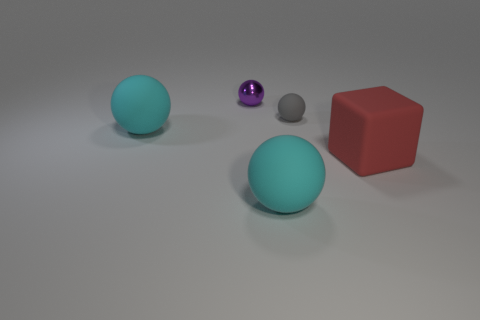There is a cyan matte ball in front of the red matte object; is it the same size as the tiny metal object?
Keep it short and to the point. No. Is the number of big cyan matte spheres in front of the large red matte block less than the number of big spheres that are to the left of the tiny gray rubber thing?
Make the answer very short. Yes. Is the matte block the same color as the metallic thing?
Provide a succinct answer. No. Are there fewer purple metal balls that are behind the small purple metal object than small gray matte balls?
Your answer should be compact. Yes. Do the big block and the purple sphere have the same material?
Provide a short and direct response. No. What number of large red blocks have the same material as the gray ball?
Ensure brevity in your answer.  1. What is the color of the tiny thing that is made of the same material as the block?
Give a very brief answer. Gray. The red rubber object is what shape?
Ensure brevity in your answer.  Cube. What material is the small object behind the gray object?
Your answer should be compact. Metal. What is the shape of the purple shiny thing that is the same size as the gray matte sphere?
Provide a short and direct response. Sphere. 